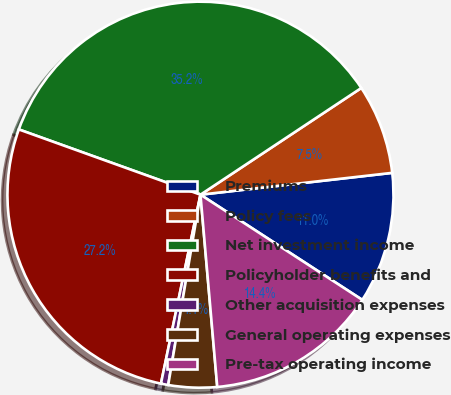Convert chart. <chart><loc_0><loc_0><loc_500><loc_500><pie_chart><fcel>Premiums<fcel>Policy fees<fcel>Net investment income<fcel>Policyholder benefits and<fcel>Other acquisition expenses<fcel>General operating expenses<fcel>Pre-tax operating income<nl><fcel>10.98%<fcel>7.52%<fcel>35.19%<fcel>27.21%<fcel>0.61%<fcel>4.06%<fcel>14.44%<nl></chart> 